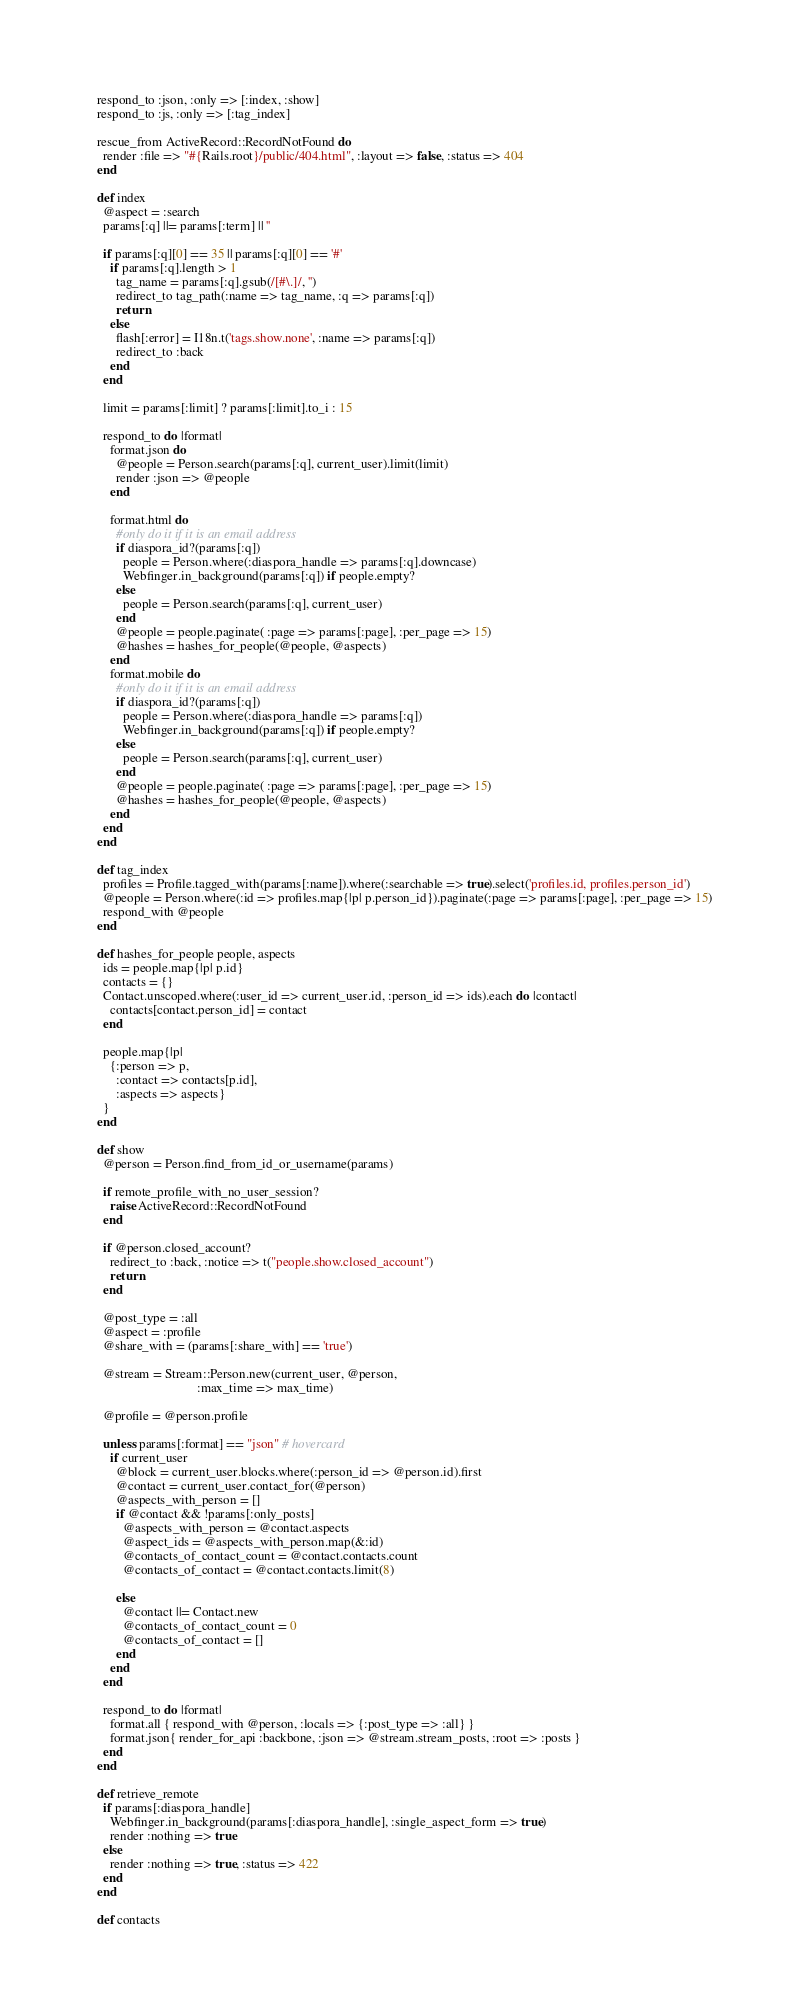<code> <loc_0><loc_0><loc_500><loc_500><_Ruby_>  respond_to :json, :only => [:index, :show]
  respond_to :js, :only => [:tag_index]

  rescue_from ActiveRecord::RecordNotFound do
    render :file => "#{Rails.root}/public/404.html", :layout => false, :status => 404
  end

  def index
    @aspect = :search
    params[:q] ||= params[:term] || ''

    if params[:q][0] == 35 || params[:q][0] == '#'
      if params[:q].length > 1
        tag_name = params[:q].gsub(/[#\.]/, '')
        redirect_to tag_path(:name => tag_name, :q => params[:q])
        return
      else
        flash[:error] = I18n.t('tags.show.none', :name => params[:q])
        redirect_to :back
      end
    end

    limit = params[:limit] ? params[:limit].to_i : 15

    respond_to do |format|
      format.json do
        @people = Person.search(params[:q], current_user).limit(limit)
        render :json => @people
      end

      format.html do
        #only do it if it is an email address
        if diaspora_id?(params[:q])
          people = Person.where(:diaspora_handle => params[:q].downcase)
          Webfinger.in_background(params[:q]) if people.empty?
        else
          people = Person.search(params[:q], current_user)
        end
        @people = people.paginate( :page => params[:page], :per_page => 15)
        @hashes = hashes_for_people(@people, @aspects)
      end
      format.mobile do
        #only do it if it is an email address
        if diaspora_id?(params[:q])
          people = Person.where(:diaspora_handle => params[:q])
          Webfinger.in_background(params[:q]) if people.empty?
        else
          people = Person.search(params[:q], current_user)
        end
        @people = people.paginate( :page => params[:page], :per_page => 15)
        @hashes = hashes_for_people(@people, @aspects)
      end
    end
  end

  def tag_index
    profiles = Profile.tagged_with(params[:name]).where(:searchable => true).select('profiles.id, profiles.person_id')
    @people = Person.where(:id => profiles.map{|p| p.person_id}).paginate(:page => params[:page], :per_page => 15)
    respond_with @people
  end

  def hashes_for_people people, aspects
    ids = people.map{|p| p.id}
    contacts = {}
    Contact.unscoped.where(:user_id => current_user.id, :person_id => ids).each do |contact|
      contacts[contact.person_id] = contact
    end

    people.map{|p|
      {:person => p,
        :contact => contacts[p.id],
        :aspects => aspects}
    }
  end

  def show
    @person = Person.find_from_id_or_username(params)

    if remote_profile_with_no_user_session?
      raise ActiveRecord::RecordNotFound
    end

    if @person.closed_account?
      redirect_to :back, :notice => t("people.show.closed_account")
      return
    end

    @post_type = :all
    @aspect = :profile
    @share_with = (params[:share_with] == 'true')

    @stream = Stream::Person.new(current_user, @person,
                                 :max_time => max_time)

    @profile = @person.profile

    unless params[:format] == "json" # hovercard
      if current_user
        @block = current_user.blocks.where(:person_id => @person.id).first
        @contact = current_user.contact_for(@person)
        @aspects_with_person = []
        if @contact && !params[:only_posts]
          @aspects_with_person = @contact.aspects
          @aspect_ids = @aspects_with_person.map(&:id)
          @contacts_of_contact_count = @contact.contacts.count
          @contacts_of_contact = @contact.contacts.limit(8)

        else
          @contact ||= Contact.new
          @contacts_of_contact_count = 0
          @contacts_of_contact = []
        end
      end
    end

    respond_to do |format|
      format.all { respond_with @person, :locals => {:post_type => :all} }
      format.json{ render_for_api :backbone, :json => @stream.stream_posts, :root => :posts }
    end
  end

  def retrieve_remote
    if params[:diaspora_handle]
      Webfinger.in_background(params[:diaspora_handle], :single_aspect_form => true)
      render :nothing => true
    else
      render :nothing => true, :status => 422
    end
  end

  def contacts</code> 